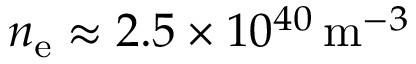Convert formula to latex. <formula><loc_0><loc_0><loc_500><loc_500>n _ { e } \approx 2 . 5 \times 1 0 ^ { 4 0 } \, m ^ { - 3 }</formula> 